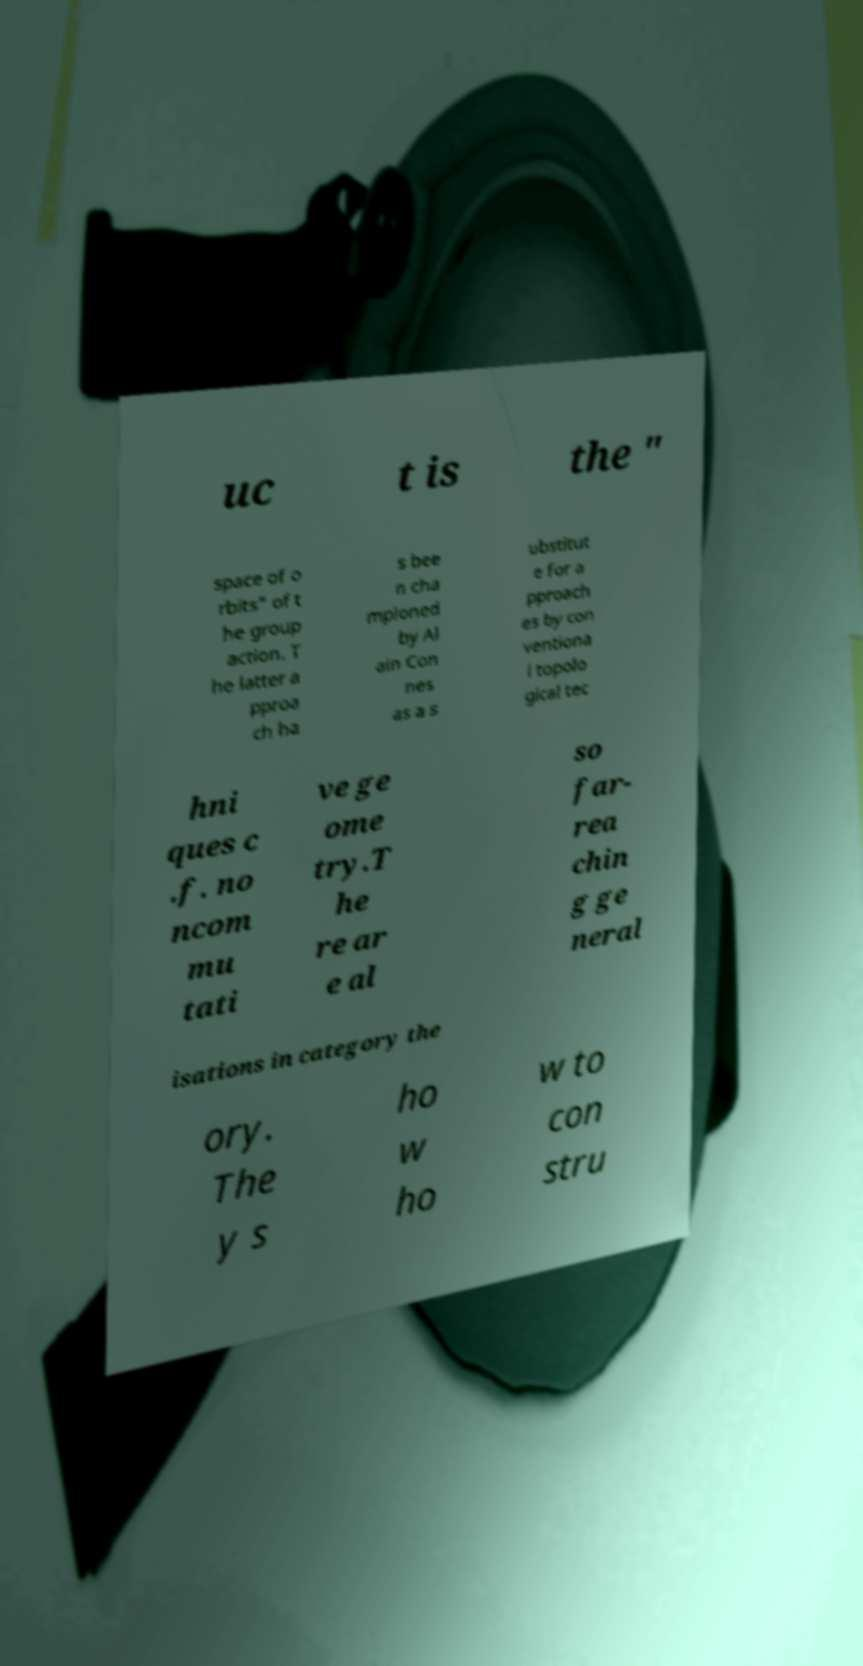Can you accurately transcribe the text from the provided image for me? uc t is the " space of o rbits" of t he group action. T he latter a pproa ch ha s bee n cha mpioned by Al ain Con nes as a s ubstitut e for a pproach es by con ventiona l topolo gical tec hni ques c .f. no ncom mu tati ve ge ome try.T he re ar e al so far- rea chin g ge neral isations in category the ory. The y s ho w ho w to con stru 